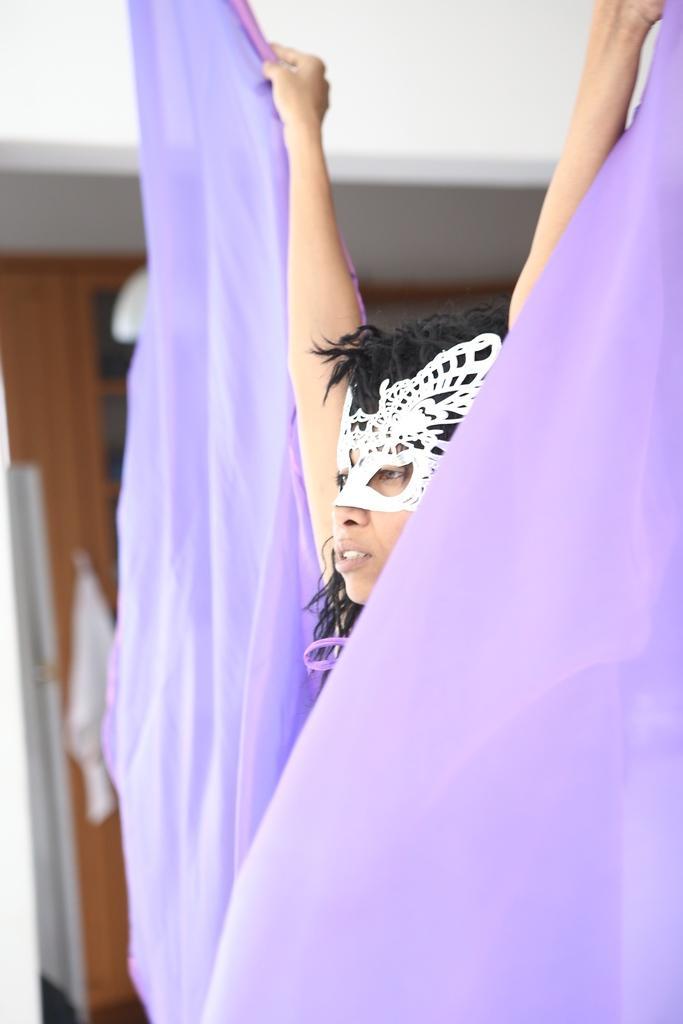How would you summarize this image in a sentence or two? In the picture we can see a woman in different costumes and raising a hand with violet color cloth and in the background, we can see a wooden wall with some rack to it. 